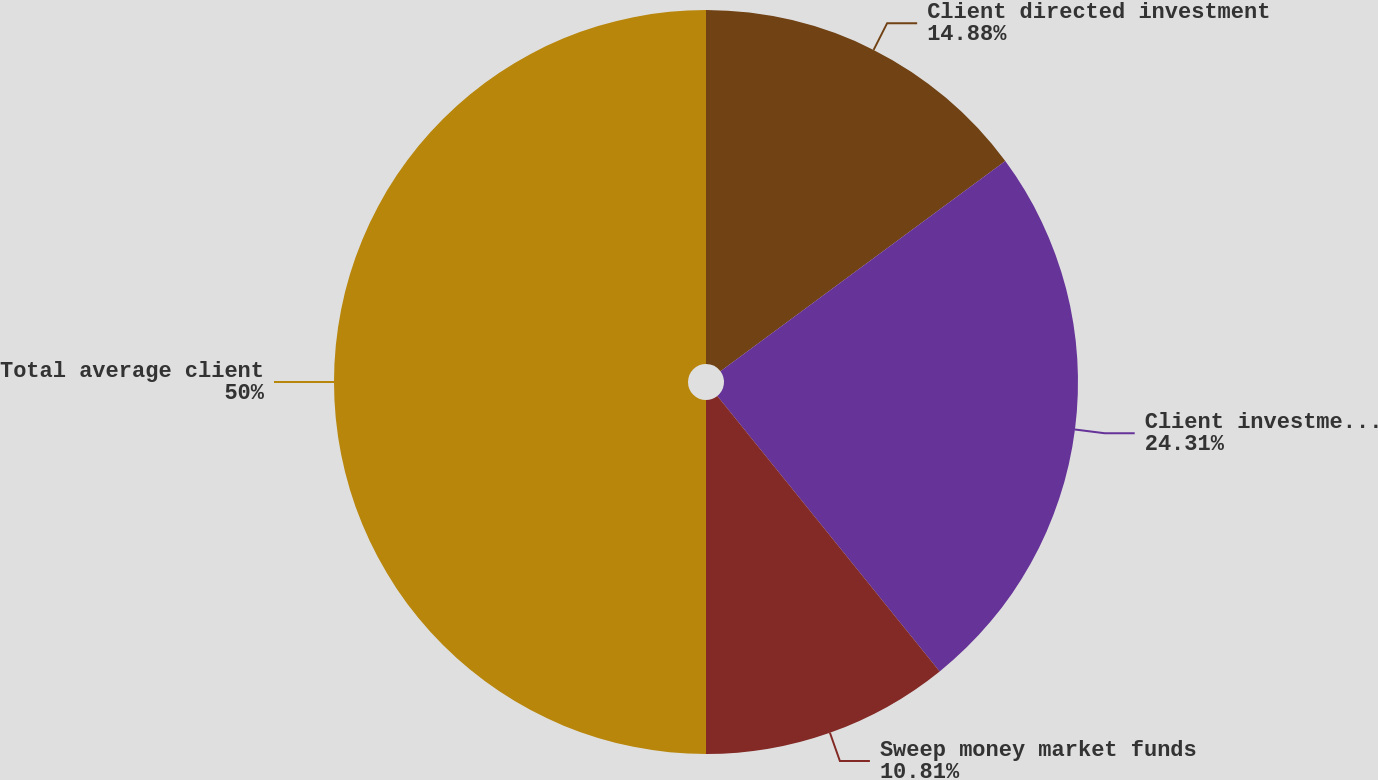Convert chart to OTSL. <chart><loc_0><loc_0><loc_500><loc_500><pie_chart><fcel>Client directed investment<fcel>Client investment assets under<fcel>Sweep money market funds<fcel>Total average client<nl><fcel>14.88%<fcel>24.31%<fcel>10.81%<fcel>50.0%<nl></chart> 